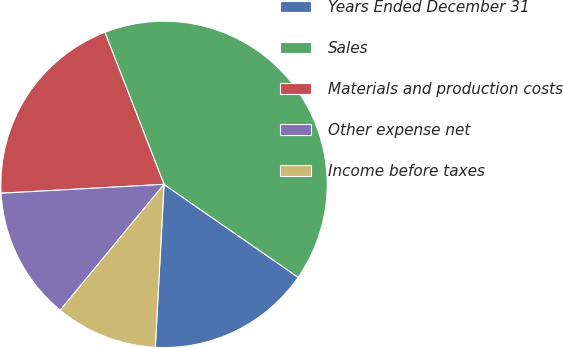Convert chart to OTSL. <chart><loc_0><loc_0><loc_500><loc_500><pie_chart><fcel>Years Ended December 31<fcel>Sales<fcel>Materials and production costs<fcel>Other expense net<fcel>Income before taxes<nl><fcel>16.21%<fcel>40.55%<fcel>19.96%<fcel>13.16%<fcel>10.12%<nl></chart> 